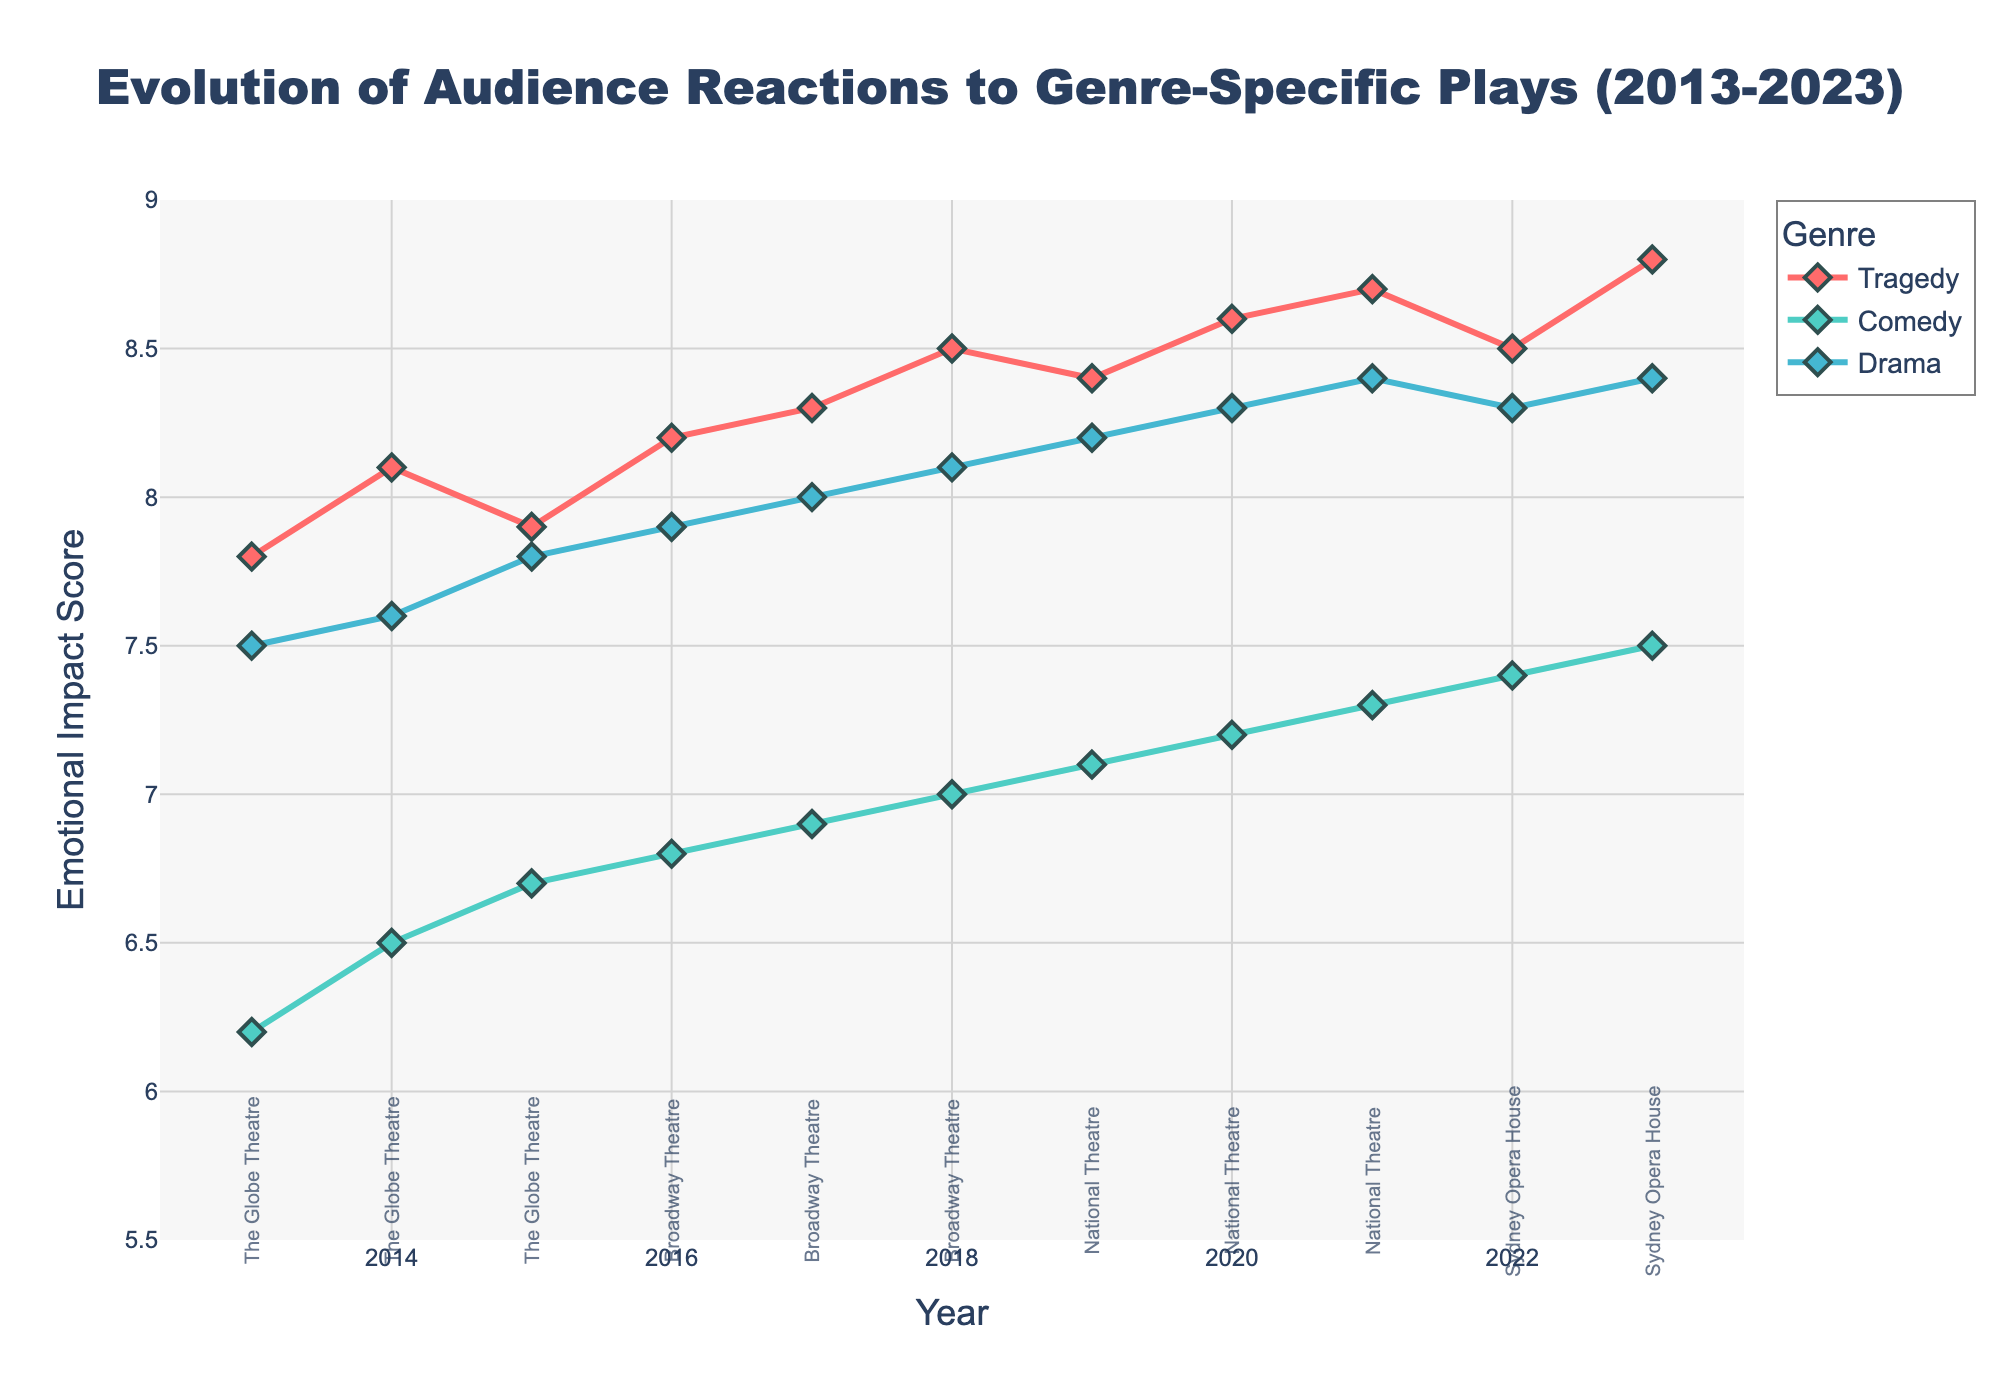What are the genres shown in the plot? The plot contains multiple lines, each representing a different genre. The legend indicates the genres: Tragedy, Comedy, and Drama.
Answer: Tragedy, Comedy, Drama What is the title of the plot? The title is displayed at the top of the plot, centered and in large font. It reads: "Evolution of Audience Reactions to Genre-Specific Plays (2013-2023)".
Answer: Evolution of Audience Reactions to Genre-Specific Plays (2013-2023) Which genre has the highest emotional impact score in 2023? Look at the values for the year 2023 on the x-axis and compare the y-axis values for each genre. The highest value corresponds to Tragedy.
Answer: Tragedy What theater hosted genre-specific plays in 2019? For the year 2019, look at the annotation near the x-axis. The annotation shows "National Theatre".
Answer: National Theatre How did the emotional impact score of Comedy change between 2013 and 2016? Check the y-axis values for Comedy at 2013 and 2016. In 2013, it is 6.2, and in 2016, it is 6.8. The score increased by 0.6 points.
Answer: Increased by 0.6 Which genre shows the most consistent increase in emotional impact score from 2013 to 2023? Analyze the trends for each genre from 2013 to 2023. Tragedy shows a steady increase in the emotional impact score throughout the decade.
Answer: Tragedy What are the colors used to represent each genre? The legend in the plot shows that Tragedy is red, Comedy is teal, and Drama is light blue.
Answer: Red (Tragedy), Teal (Comedy), Light Blue (Drama) What is the range of the emotional impact scores on the y-axis? The y-axis labels show the range starting from 5.5 to 9.
Answer: 5.5 to 9 Which genre had the lowest variance in emotional impact scores over the decade? By examining the fluctuations in the lines, Drama shows the least amount of fluctuation and is more consistent.
Answer: Drama What is the average emotional impact score of Tragedy for the first five years (2013-2017)? Sum the scores for Tragedy from 2013 to 2017: (7.8 + 8.1 + 7.9 + 8.2 + 8.3) = 40.3. Divide by 5 to get the average: 40.3/5 = 8.06.
Answer: 8.06 